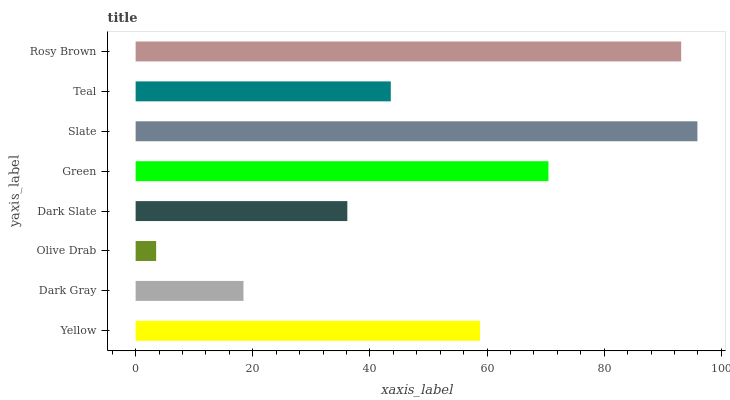Is Olive Drab the minimum?
Answer yes or no. Yes. Is Slate the maximum?
Answer yes or no. Yes. Is Dark Gray the minimum?
Answer yes or no. No. Is Dark Gray the maximum?
Answer yes or no. No. Is Yellow greater than Dark Gray?
Answer yes or no. Yes. Is Dark Gray less than Yellow?
Answer yes or no. Yes. Is Dark Gray greater than Yellow?
Answer yes or no. No. Is Yellow less than Dark Gray?
Answer yes or no. No. Is Yellow the high median?
Answer yes or no. Yes. Is Teal the low median?
Answer yes or no. Yes. Is Teal the high median?
Answer yes or no. No. Is Dark Slate the low median?
Answer yes or no. No. 